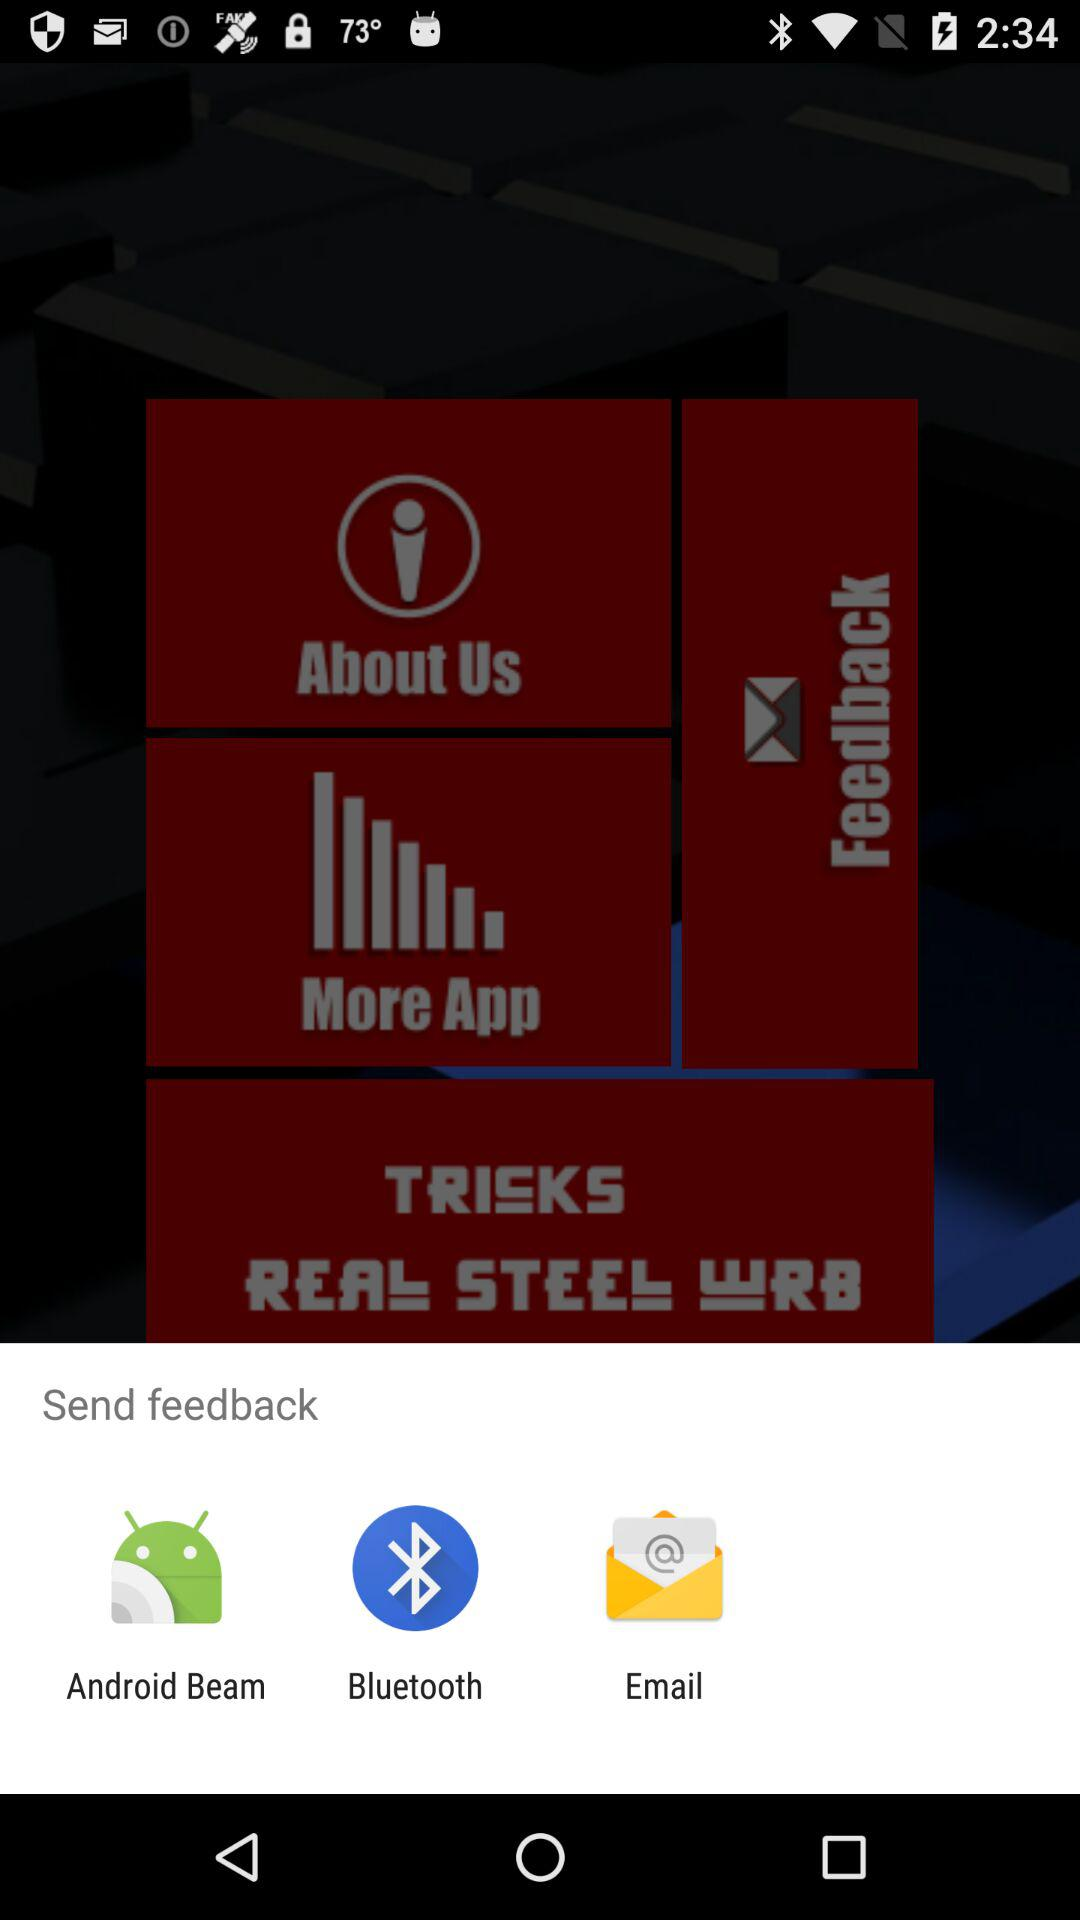What are the options available for sending feedback? The options available for sending feedback are "Android Beam", "Bluetooth" and "Email". 